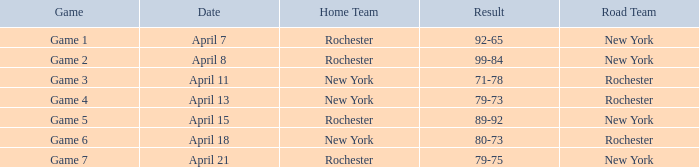Which visiting team played against rochester's home team and had a score of 89-92? New York. 